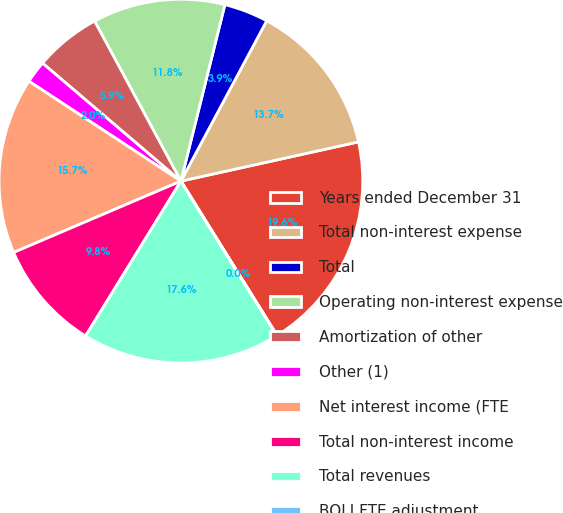Convert chart to OTSL. <chart><loc_0><loc_0><loc_500><loc_500><pie_chart><fcel>Years ended December 31<fcel>Total non-interest expense<fcel>Total<fcel>Operating non-interest expense<fcel>Amortization of other<fcel>Other (1)<fcel>Net interest income (FTE<fcel>Total non-interest income<fcel>Total revenues<fcel>BOLI FTE adjustment<nl><fcel>19.59%<fcel>13.72%<fcel>3.93%<fcel>11.76%<fcel>5.89%<fcel>1.98%<fcel>15.67%<fcel>9.8%<fcel>17.63%<fcel>0.02%<nl></chart> 